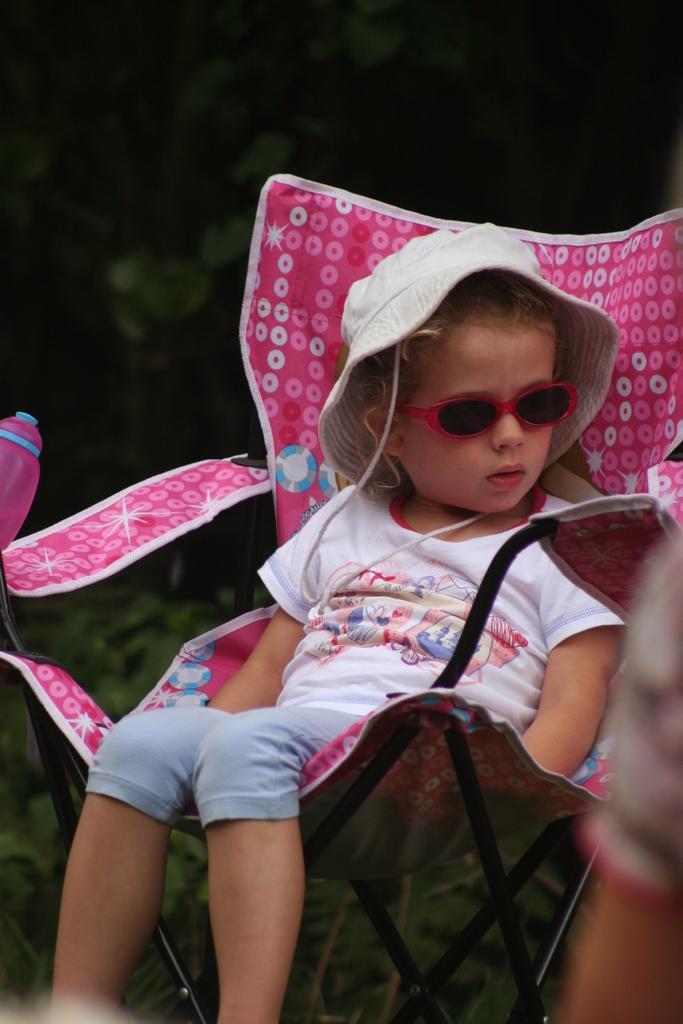Can you describe this image briefly? In this picture I can see there is a girl sitting on the chair and she is wearing a white shirt, pant, a cap and glasses and she is looking at right side. In the backdrop it looks like there are plants and the backdrop is blurred. 